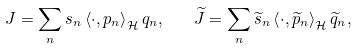<formula> <loc_0><loc_0><loc_500><loc_500>J = \sum _ { n } s _ { n } \left \langle \cdot , p _ { n } \right \rangle _ { \mathcal { H } } q _ { n } , \quad \widetilde { J } = \sum _ { n } \widetilde { s } _ { n } \left \langle \cdot , \widetilde { p } _ { n } \right \rangle _ { \mathcal { H } } \widetilde { q } _ { n } ,</formula> 